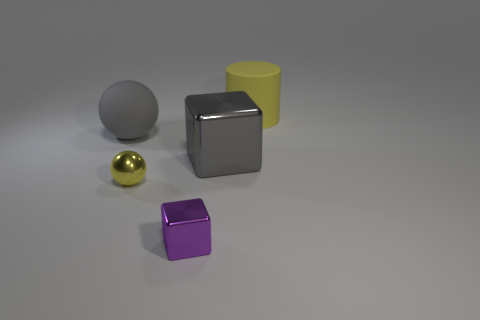Which object in the image appears to be the largest? The largest object in the image looks to be the silver cube. Its dimensions are greater than those of the other objects when viewed from this perspective. 